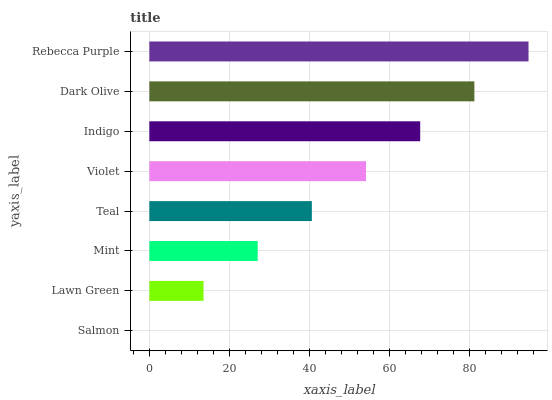Is Salmon the minimum?
Answer yes or no. Yes. Is Rebecca Purple the maximum?
Answer yes or no. Yes. Is Lawn Green the minimum?
Answer yes or no. No. Is Lawn Green the maximum?
Answer yes or no. No. Is Lawn Green greater than Salmon?
Answer yes or no. Yes. Is Salmon less than Lawn Green?
Answer yes or no. Yes. Is Salmon greater than Lawn Green?
Answer yes or no. No. Is Lawn Green less than Salmon?
Answer yes or no. No. Is Violet the high median?
Answer yes or no. Yes. Is Teal the low median?
Answer yes or no. Yes. Is Indigo the high median?
Answer yes or no. No. Is Indigo the low median?
Answer yes or no. No. 